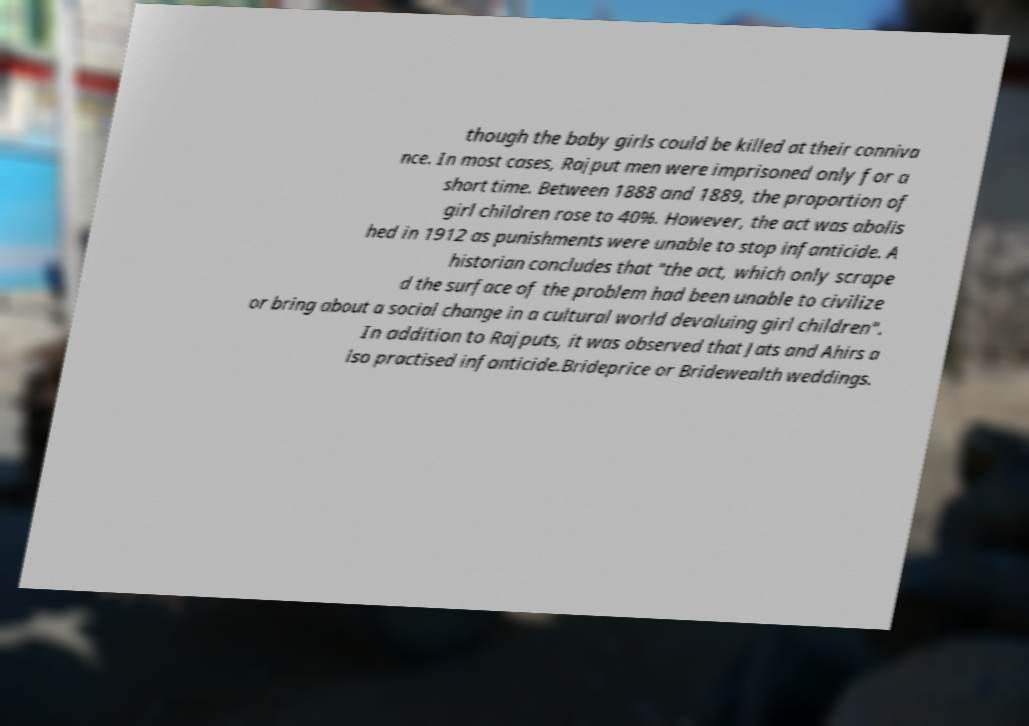Could you assist in decoding the text presented in this image and type it out clearly? though the baby girls could be killed at their conniva nce. In most cases, Rajput men were imprisoned only for a short time. Between 1888 and 1889, the proportion of girl children rose to 40%. However, the act was abolis hed in 1912 as punishments were unable to stop infanticide. A historian concludes that "the act, which only scrape d the surface of the problem had been unable to civilize or bring about a social change in a cultural world devaluing girl children". In addition to Rajputs, it was observed that Jats and Ahirs a lso practised infanticide.Brideprice or Bridewealth weddings. 